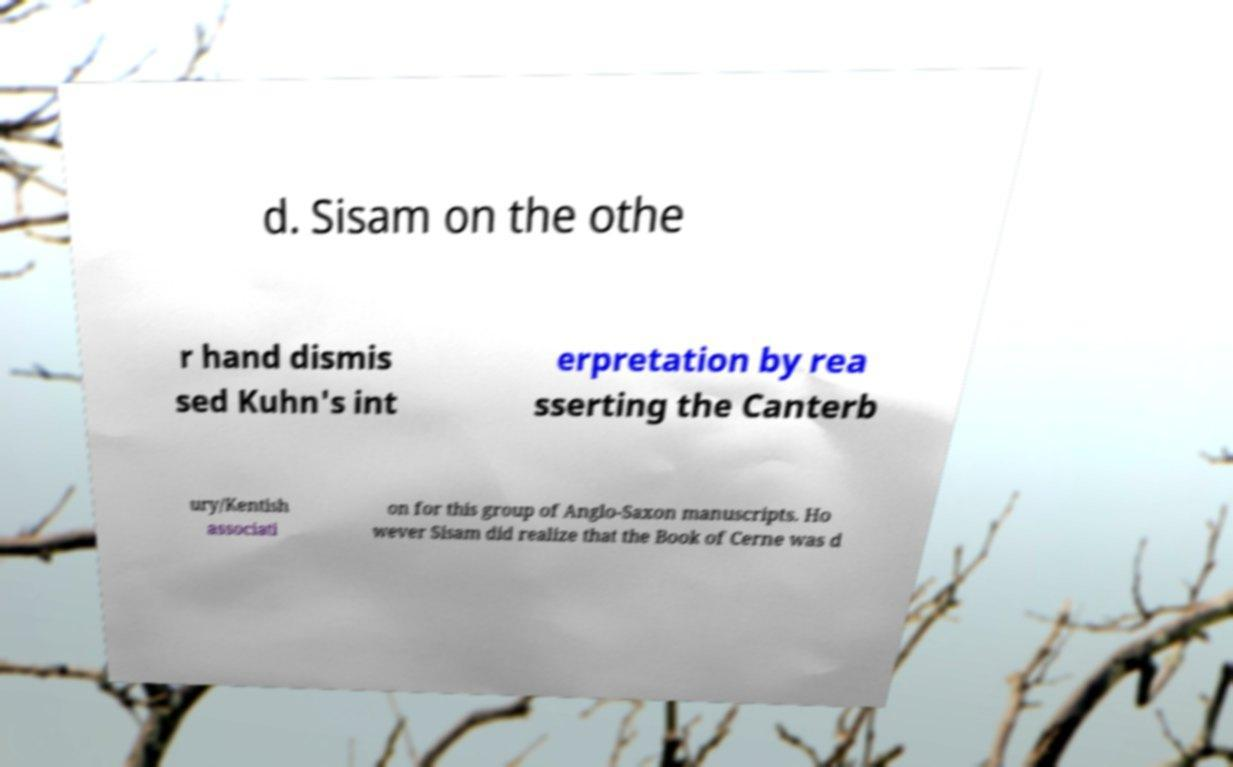Could you extract and type out the text from this image? d. Sisam on the othe r hand dismis sed Kuhn's int erpretation by rea sserting the Canterb ury/Kentish associati on for this group of Anglo-Saxon manuscripts. Ho wever Sisam did realize that the Book of Cerne was d 